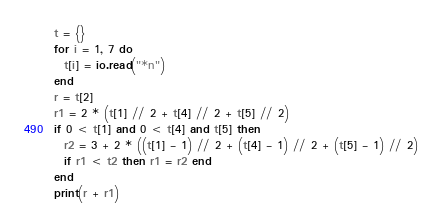Convert code to text. <code><loc_0><loc_0><loc_500><loc_500><_Lua_>t = {}
for i = 1, 7 do
  t[i] = io.read("*n")
end
r = t[2]
r1 = 2 * (t[1] // 2 + t[4] // 2 + t[5] // 2)
if 0 < t[1] and 0 < t[4] and t[5] then
  r2 = 3 + 2 * ((t[1] - 1) // 2 + (t[4] - 1) // 2 + (t[5] - 1) // 2)
  if r1 < t2 then r1 = r2 end
end
print(r + r1)
</code> 